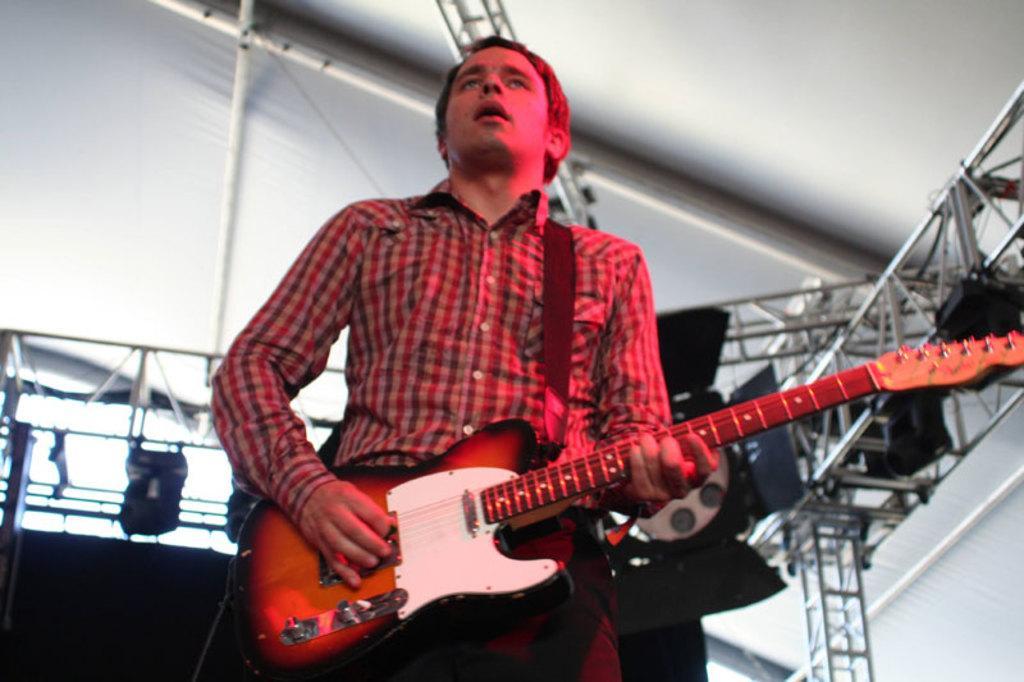How would you summarize this image in a sentence or two? In this picture there is a man who is playing a guitar. 